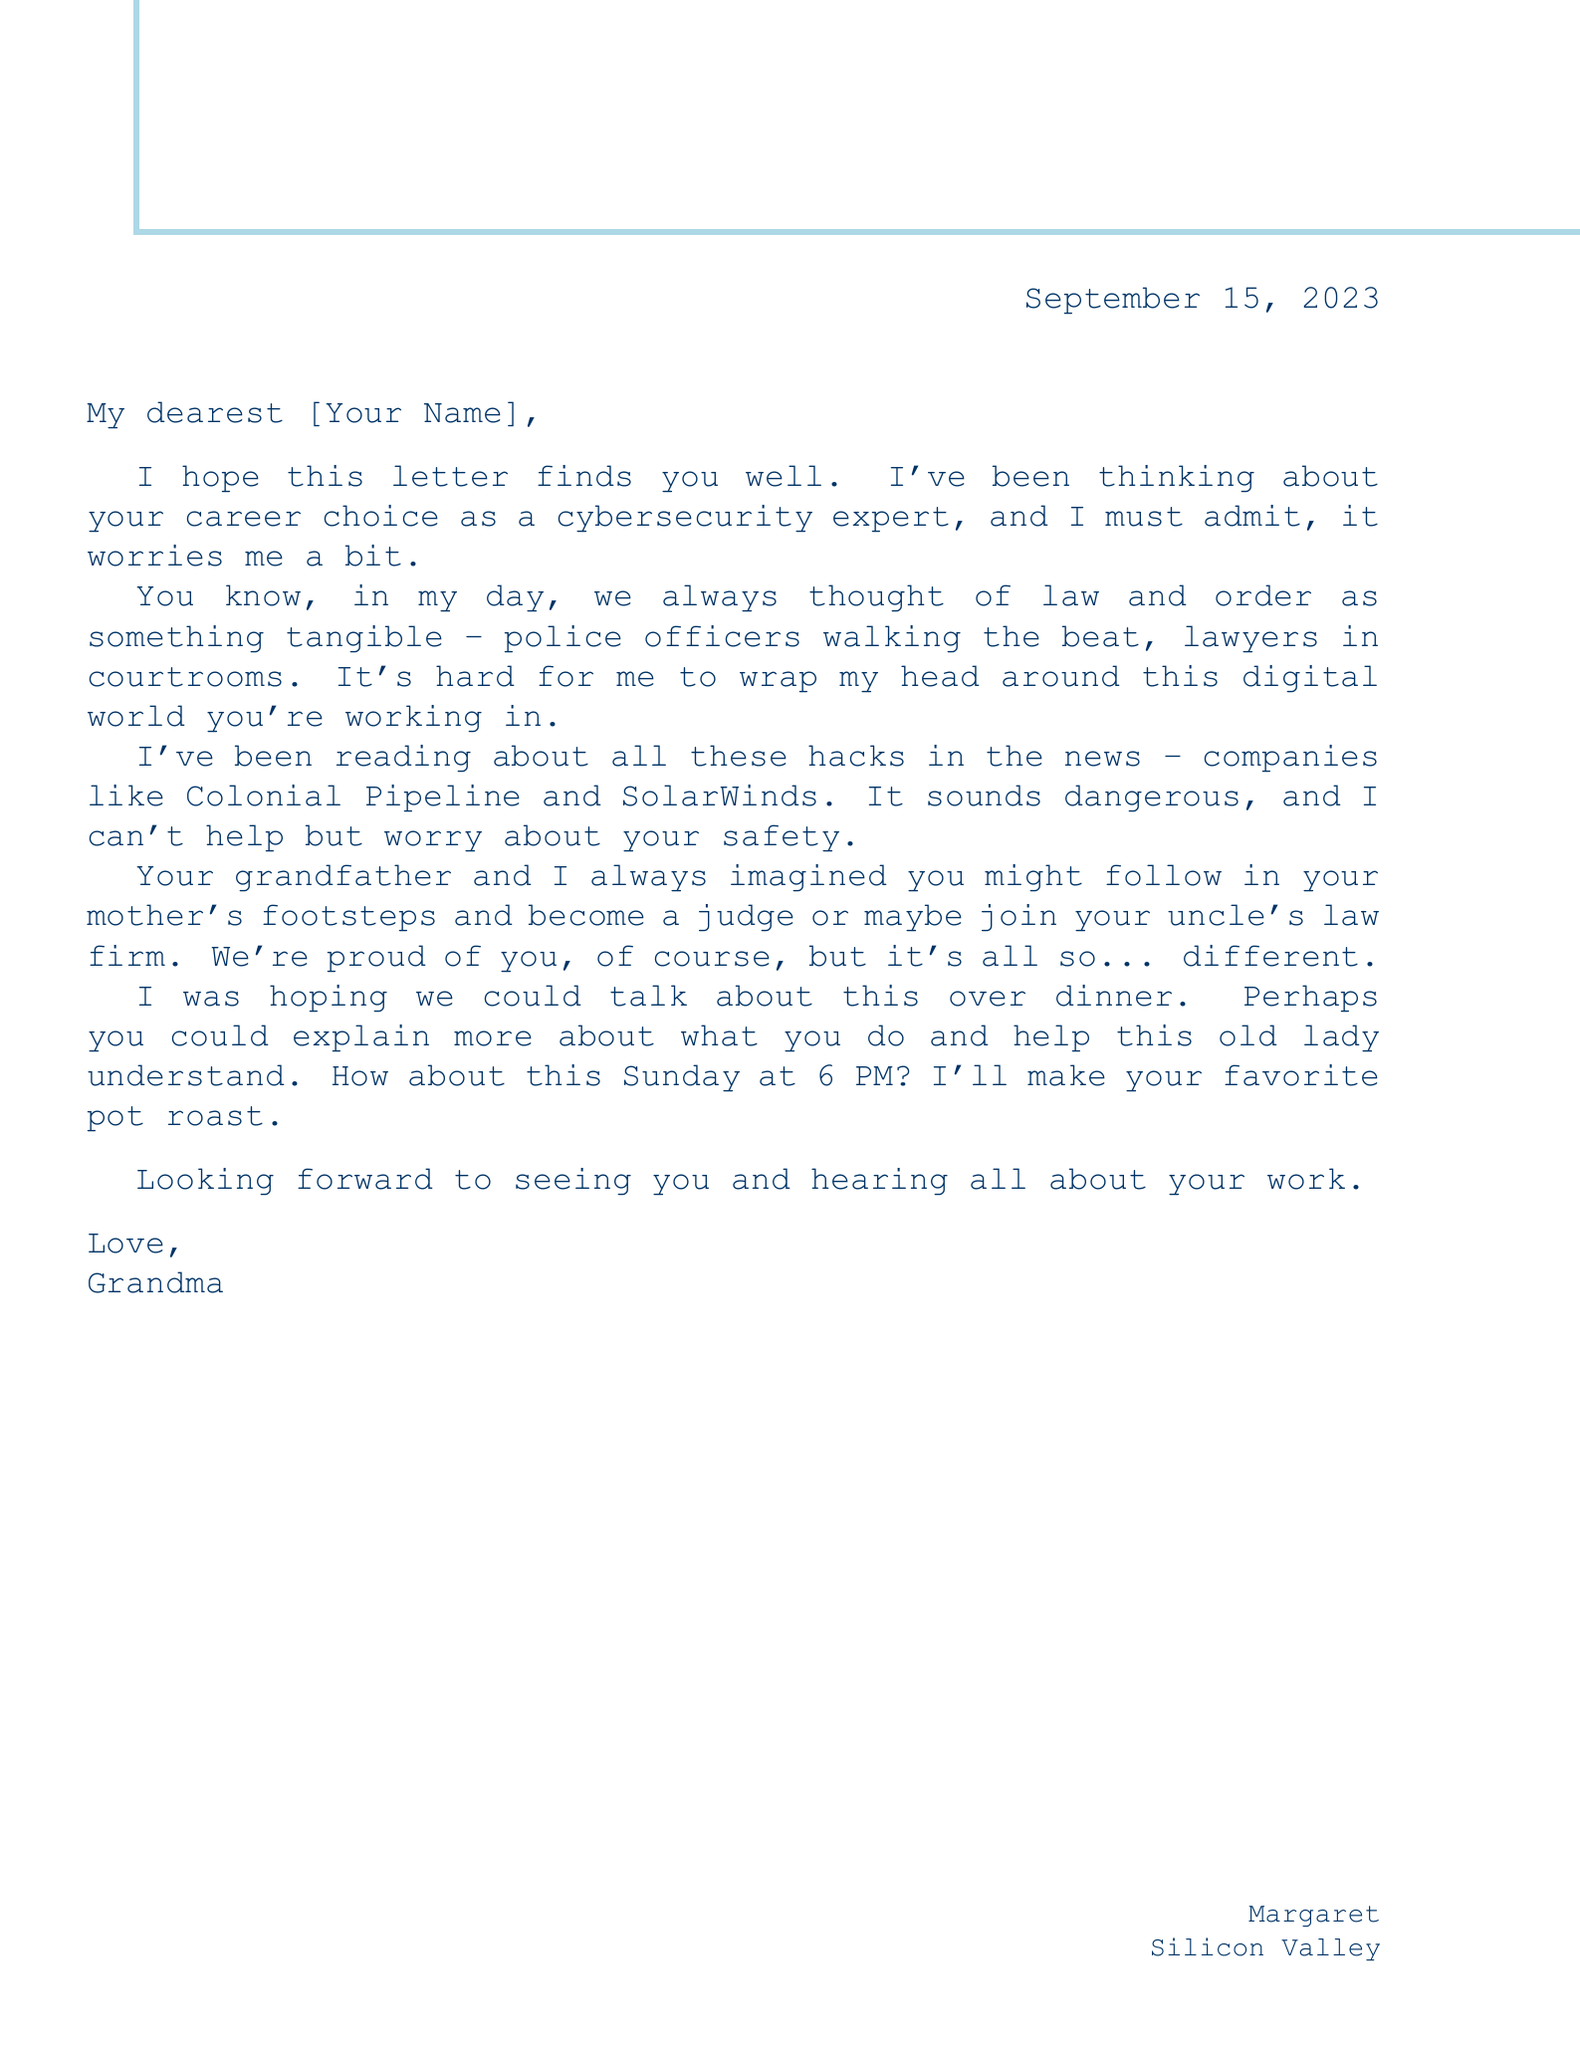what is the date of the letter? The date of the letter is specified in the header of the document.
Answer: September 15, 2023 who is the letter addressed to? The salutation at the beginning of the document indicates who the letter is addressed to.
Answer: [Your Name] what career choice does Grandma express concern about? The body of the letter explicitly states Grandma's concern regarding the grandchild's career.
Answer: cybersecurity expert what traditional career does Grandma mention? Grandma refers to traditional career paths she is familiar with in her day.
Answer: judge what invitation does Grandma extend? The letter body includes a clear invitation from Grandma regarding a meeting.
Answer: dinner what time does Grandma suggest for dinner? Grandma proposes a specific time for dinner in the letter.
Answer: 6 PM which dish will Grandma cook? The letter mentions a particular dish Grandma plans to prepare for dinner.
Answer: pot roast what does Grandma want to discuss? The letter states that Grandma would like to understand more about the grandchild's work, indicating the topic of discussion.
Answer: work how does Grandma sign off the letter? The closing of the letter provides a signature.
Answer: Love, Grandma 